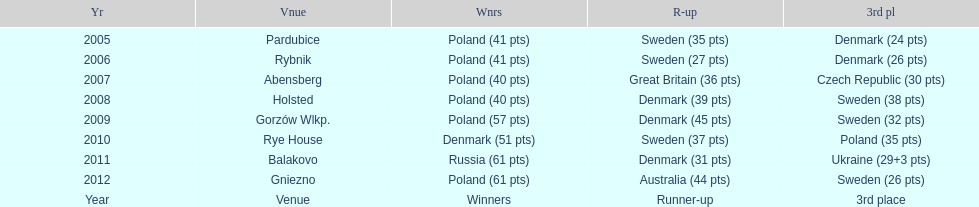What was the difference in final score between russia and denmark in 2011? 30. 